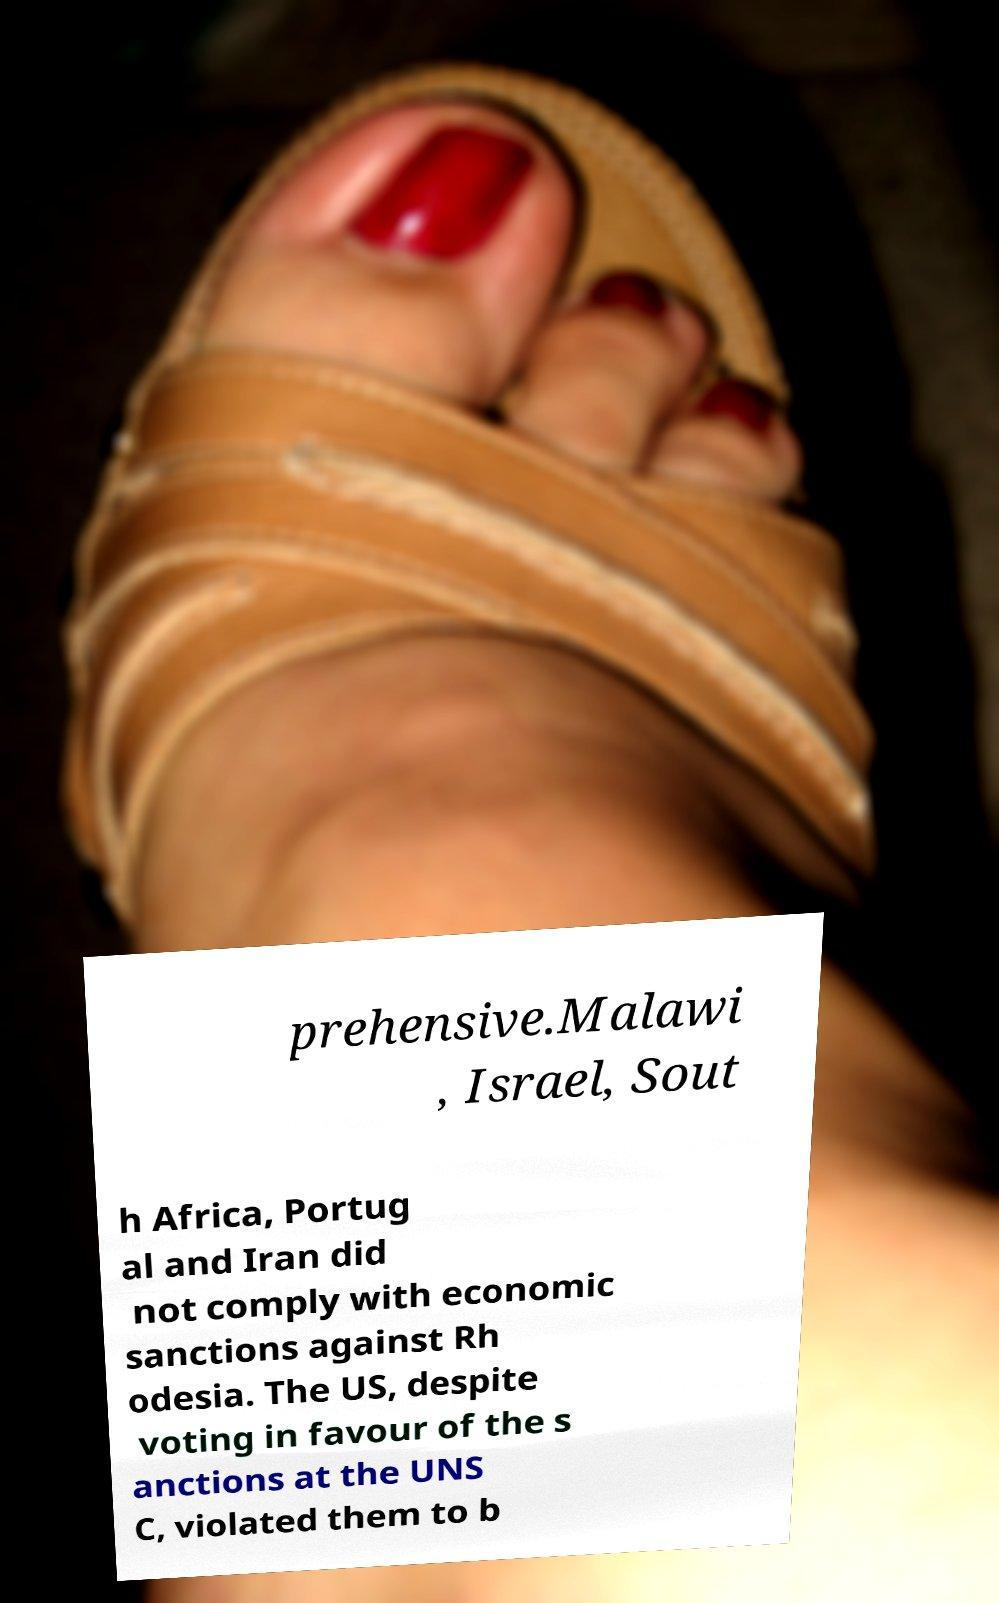Please read and relay the text visible in this image. What does it say? prehensive.Malawi , Israel, Sout h Africa, Portug al and Iran did not comply with economic sanctions against Rh odesia. The US, despite voting in favour of the s anctions at the UNS C, violated them to b 